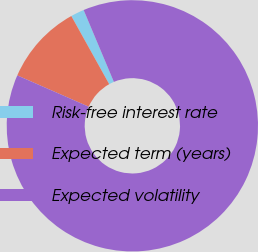Convert chart. <chart><loc_0><loc_0><loc_500><loc_500><pie_chart><fcel>Risk-free interest rate<fcel>Expected term (years)<fcel>Expected volatility<nl><fcel>1.74%<fcel>10.35%<fcel>87.92%<nl></chart> 